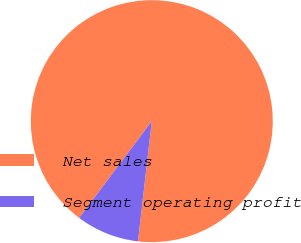Convert chart. <chart><loc_0><loc_0><loc_500><loc_500><pie_chart><fcel>Net sales<fcel>Segment operating profit<nl><fcel>91.57%<fcel>8.43%<nl></chart> 